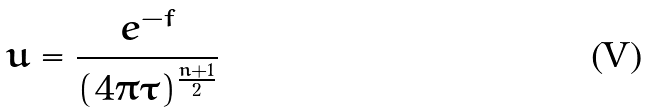Convert formula to latex. <formula><loc_0><loc_0><loc_500><loc_500>u = \frac { e ^ { - f } } { ( 4 \pi \tau ) ^ { \frac { n + 1 } { 2 } } }</formula> 